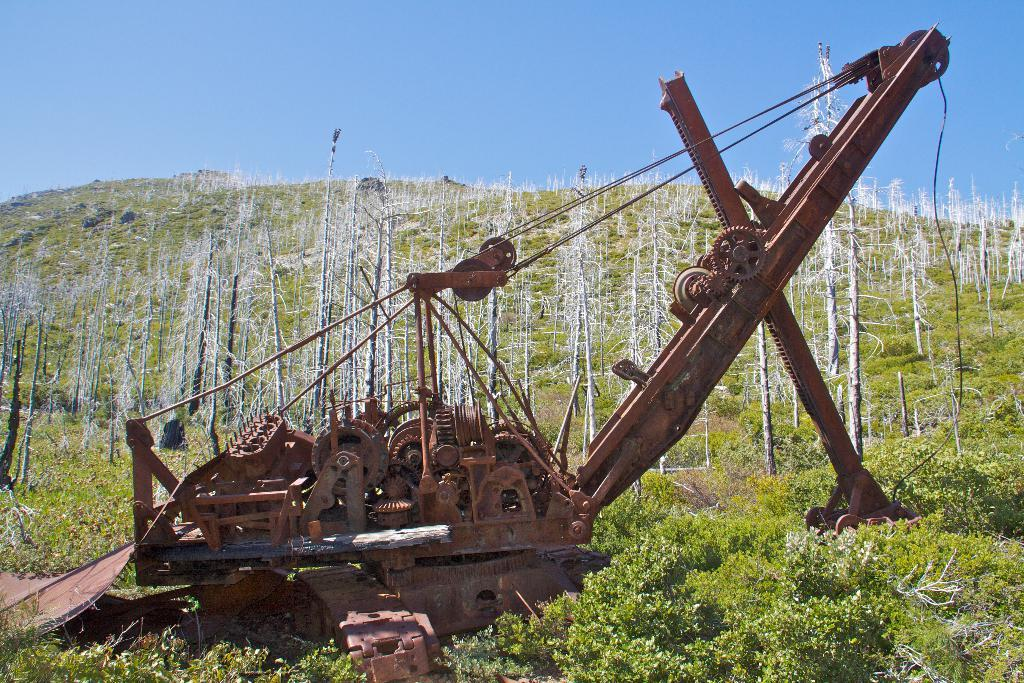What is the main object in the middle of the image? There is an iron machine in the middle of the image. What can be seen at the back side of the image? There are trees at the back side of the image. What is visible at the top of the image? The sky is visible at the top of the image. What color is the sky in the image? The sky is blue in color. How many bulbs are used to light up the oven in the image? There is no oven present in the image, and therefore no bulbs are used to light it up. 